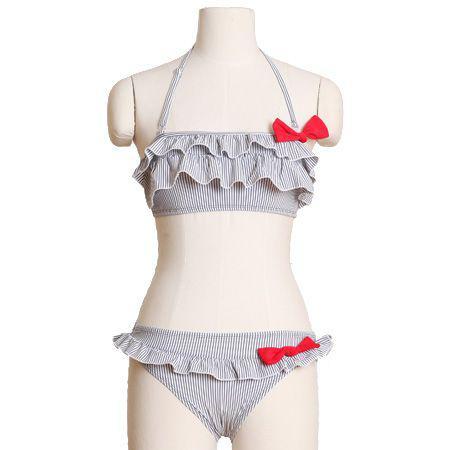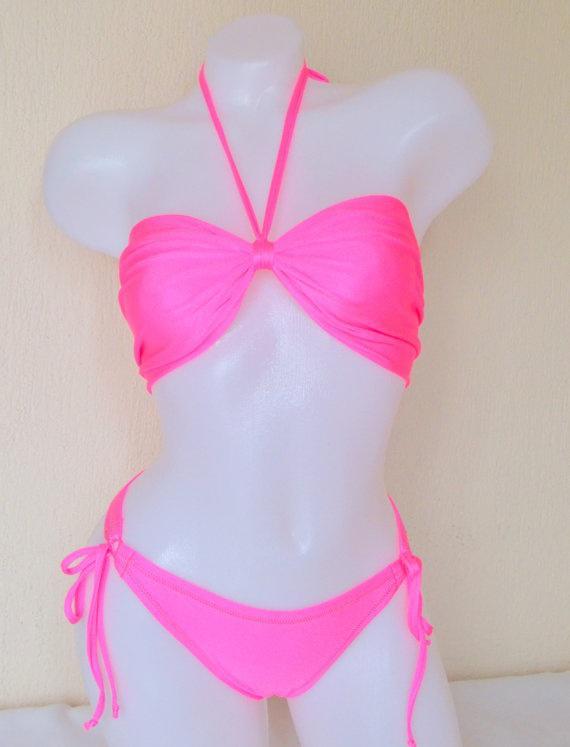The first image is the image on the left, the second image is the image on the right. For the images displayed, is the sentence "There is not less than one mannequin" factually correct? Answer yes or no. Yes. 